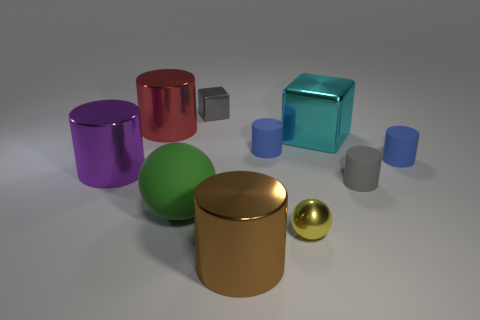What material is the small blue cylinder left of the blue rubber cylinder that is to the right of the big cyan metallic block?
Give a very brief answer. Rubber. How many objects are either big things that are to the left of the cyan cube or small blue cylinders?
Offer a very short reply. 6. Is the number of big cubes that are left of the cyan block the same as the number of large purple objects that are left of the gray shiny cube?
Provide a short and direct response. No. There is a big object that is to the right of the metal cylinder that is on the right side of the small object that is to the left of the brown cylinder; what is it made of?
Offer a very short reply. Metal. There is a matte thing that is on the right side of the green object and to the left of the small yellow sphere; how big is it?
Your answer should be very brief. Small. Is the tiny gray metallic object the same shape as the gray matte object?
Provide a succinct answer. No. What shape is the gray thing that is made of the same material as the big green ball?
Keep it short and to the point. Cylinder. What number of tiny things are blue matte cylinders or metal things?
Your response must be concise. 4. Is there a large green sphere that is behind the matte cylinder in front of the large purple object?
Give a very brief answer. No. Are any tiny red shiny things visible?
Your response must be concise. No. 